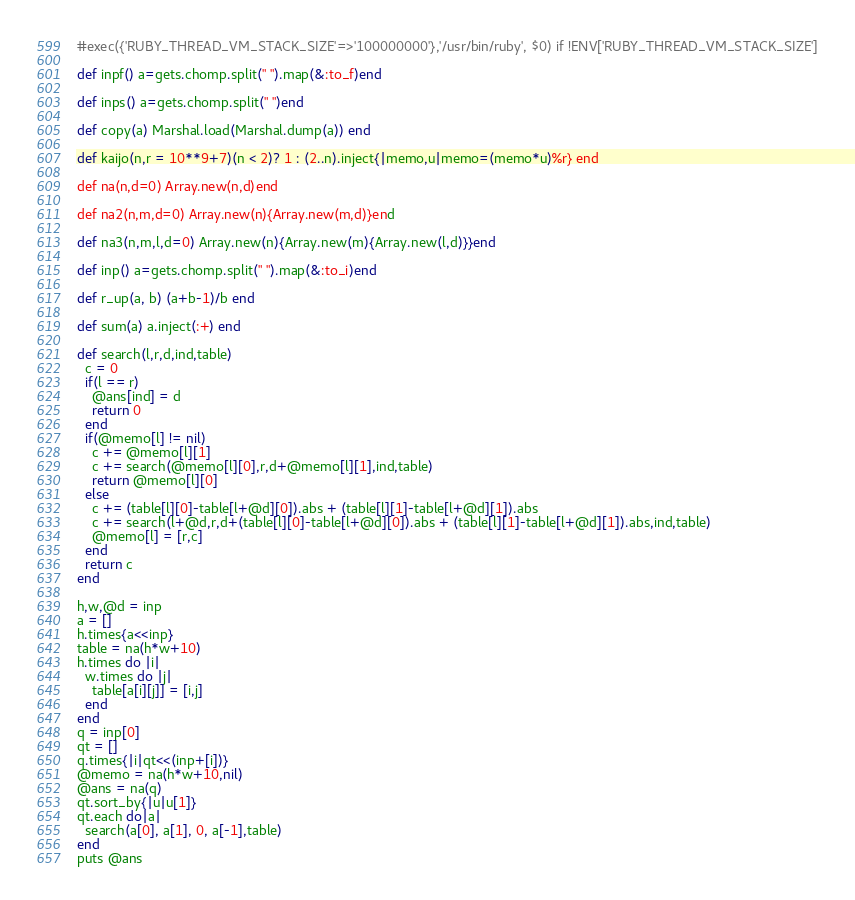<code> <loc_0><loc_0><loc_500><loc_500><_Ruby_>#exec({'RUBY_THREAD_VM_STACK_SIZE'=>'100000000'},'/usr/bin/ruby', $0) if !ENV['RUBY_THREAD_VM_STACK_SIZE']

def inpf() a=gets.chomp.split(" ").map(&:to_f)end

def inps() a=gets.chomp.split(" ")end

def copy(a) Marshal.load(Marshal.dump(a)) end

def kaijo(n,r = 10**9+7)(n < 2)? 1 : (2..n).inject{|memo,u|memo=(memo*u)%r} end

def na(n,d=0) Array.new(n,d)end

def na2(n,m,d=0) Array.new(n){Array.new(m,d)}end

def na3(n,m,l,d=0) Array.new(n){Array.new(m){Array.new(l,d)}}end

def inp() a=gets.chomp.split(" ").map(&:to_i)end

def r_up(a, b) (a+b-1)/b end

def sum(a) a.inject(:+) end

def search(l,r,d,ind,table)
  c = 0
  if(l == r)
    @ans[ind] = d
    return 0
  end
  if(@memo[l] != nil)
    c += @memo[l][1]
    c += search(@memo[l][0],r,d+@memo[l][1],ind,table)
    return @memo[l][0]
  else
    c += (table[l][0]-table[l+@d][0]).abs + (table[l][1]-table[l+@d][1]).abs
    c += search(l+@d,r,d+(table[l][0]-table[l+@d][0]).abs + (table[l][1]-table[l+@d][1]).abs,ind,table)
    @memo[l] = [r,c]
  end
  return c
end

h,w,@d = inp
a = []
h.times{a<<inp}
table = na(h*w+10)
h.times do |i|
  w.times do |j|
    table[a[i][j]] = [i,j]
  end
end
q = inp[0]
qt = []
q.times{|i|qt<<(inp+[i])}
@memo = na(h*w+10,nil)
@ans = na(q)
qt.sort_by{|u|u[1]}
qt.each do|a|
  search(a[0], a[1], 0, a[-1],table)
end
puts @ans</code> 